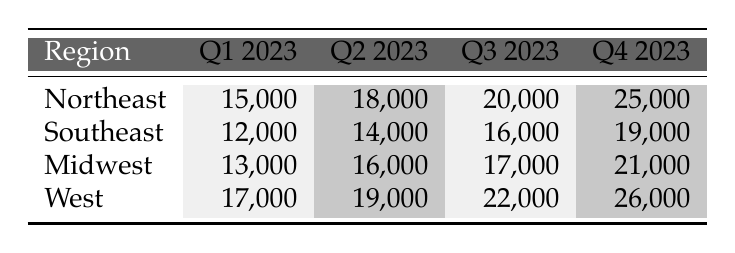What is the total sales in Q1 2023 across all regions? To find the total sales in Q1 2023, I will add the sales figures for each region during that quarter: Northeast (15,000) + Southeast (12,000) + Midwest (13,000) + West (17,000) = 57,000.
Answer: 57,000 Which region had the highest sales in Q4 2023? By comparing the sales figures for Q4 2023 across all regions, I see that the Northeast had sales of 25,000, the Southeast had 19,000, the Midwest had 21,000, and the West had 26,000. The highest figure is for the West.
Answer: West What were the sales figures for the Midwest in Q2 and Q4 combined? I will add the Q2 sales figure for the Midwest (16,000) to the Q4 sales figure (21,000): 16,000 + 21,000 = 37,000.
Answer: 37,000 Is the sales growth from Q1 to Q2 in the Southeast greater than in the Northeast? First, I will calculate the growth in sales from Q1 to Q2 for both regions: Southeast had a growth of (14,000 - 12,000) = 2,000, and Northeast had a growth of (18,000 - 15,000) = 3,000. Since 2,000 is not greater than 3,000, the answer is no.
Answer: No What is the average sales figure for Q3 across all regions? I will first sum the Q3 sales figures: Northeast (20,000) + Southeast (16,000) + Midwest (17,000) + West (22,000) = 75,000. Then, I divide this total by the number of regions (4): 75,000 / 4 = 18,750.
Answer: 18,750 During which quarter did the Midwest experience its highest sales? I will compare the sales figures for the Midwest across all quarters: Q1 (13,000), Q2 (16,000), Q3 (17,000), and Q4 (21,000). The highest figure is for Q4.
Answer: Q4 2023 Did the sales in the Northeast increase every quarter in 2023? I check the sales figures for the Northeast: Q1 (15,000), Q2 (18,000), Q3 (20,000), and Q4 (25,000). Since each subsequent quarter shows a higher figure, the answer is yes.
Answer: Yes What is the difference in sales between the highest and lowest region in Q2 2023? I look at the Q2 sales figures: Northeast (18,000), Southeast (14,000), Midwest (16,000), West (19,000). The highest is West (19,000) and the lowest is Southeast (14,000). The difference is 19,000 - 14,000 = 5,000.
Answer: 5,000 